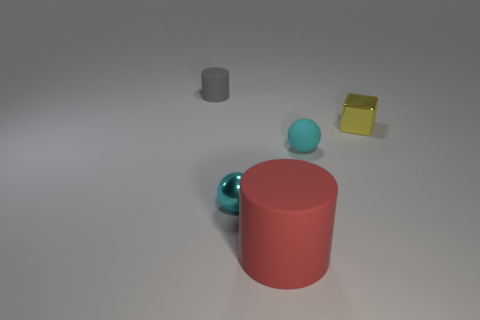What number of yellow metallic blocks have the same size as the red rubber cylinder?
Keep it short and to the point. 0. There is a metal thing that is the same color as the matte sphere; what size is it?
Your response must be concise. Small. Is the metallic cube the same color as the rubber sphere?
Give a very brief answer. No. What is the shape of the large red rubber thing?
Give a very brief answer. Cylinder. Are there any large spheres of the same color as the tiny matte sphere?
Keep it short and to the point. No. Are there more tiny things on the right side of the gray matte object than blue shiny spheres?
Your answer should be compact. Yes. Do the big red thing and the tiny metallic object on the right side of the metallic sphere have the same shape?
Keep it short and to the point. No. Is there a purple shiny cylinder?
Your response must be concise. No. How many small objects are either cyan rubber objects or yellow cubes?
Make the answer very short. 2. Is the number of big red matte things on the right side of the tiny shiny cube greater than the number of large cylinders that are behind the cyan matte sphere?
Offer a terse response. No. 